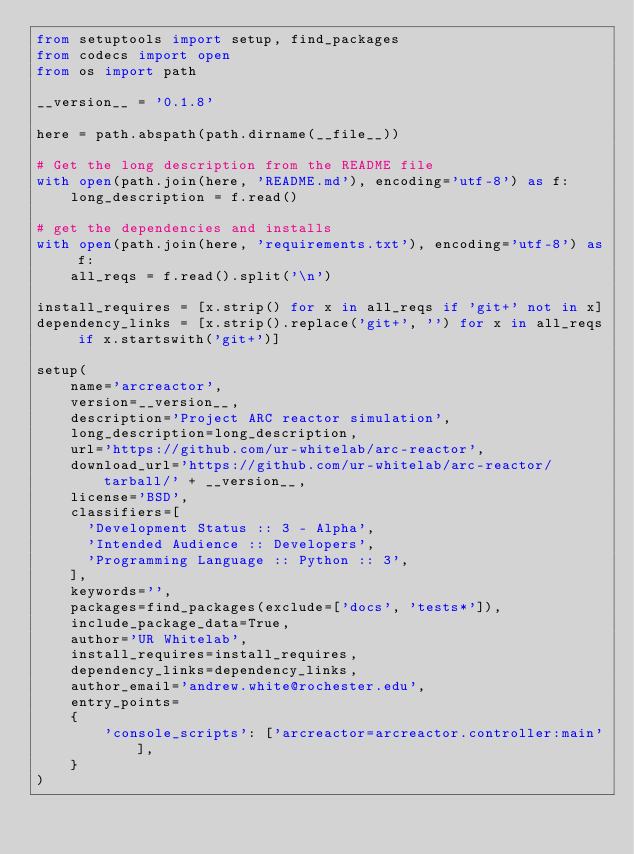<code> <loc_0><loc_0><loc_500><loc_500><_Python_>from setuptools import setup, find_packages
from codecs import open
from os import path

__version__ = '0.1.8'

here = path.abspath(path.dirname(__file__))

# Get the long description from the README file
with open(path.join(here, 'README.md'), encoding='utf-8') as f:
    long_description = f.read()

# get the dependencies and installs
with open(path.join(here, 'requirements.txt'), encoding='utf-8') as f:
    all_reqs = f.read().split('\n')

install_requires = [x.strip() for x in all_reqs if 'git+' not in x]
dependency_links = [x.strip().replace('git+', '') for x in all_reqs if x.startswith('git+')]

setup(
    name='arcreactor',
    version=__version__,
    description='Project ARC reactor simulation',
    long_description=long_description,
    url='https://github.com/ur-whitelab/arc-reactor',
    download_url='https://github.com/ur-whitelab/arc-reactor/tarball/' + __version__,
    license='BSD',
    classifiers=[
      'Development Status :: 3 - Alpha',
      'Intended Audience :: Developers',
      'Programming Language :: Python :: 3',
    ],
    keywords='',
    packages=find_packages(exclude=['docs', 'tests*']),
    include_package_data=True,
    author='UR Whitelab',
    install_requires=install_requires,
    dependency_links=dependency_links,
    author_email='andrew.white@rochester.edu',
    entry_points=
    {
        'console_scripts': ['arcreactor=arcreactor.controller:main'],
    }
)
</code> 